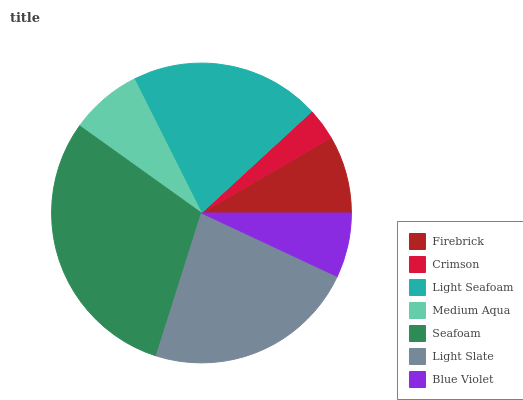Is Crimson the minimum?
Answer yes or no. Yes. Is Seafoam the maximum?
Answer yes or no. Yes. Is Light Seafoam the minimum?
Answer yes or no. No. Is Light Seafoam the maximum?
Answer yes or no. No. Is Light Seafoam greater than Crimson?
Answer yes or no. Yes. Is Crimson less than Light Seafoam?
Answer yes or no. Yes. Is Crimson greater than Light Seafoam?
Answer yes or no. No. Is Light Seafoam less than Crimson?
Answer yes or no. No. Is Firebrick the high median?
Answer yes or no. Yes. Is Firebrick the low median?
Answer yes or no. Yes. Is Medium Aqua the high median?
Answer yes or no. No. Is Light Slate the low median?
Answer yes or no. No. 